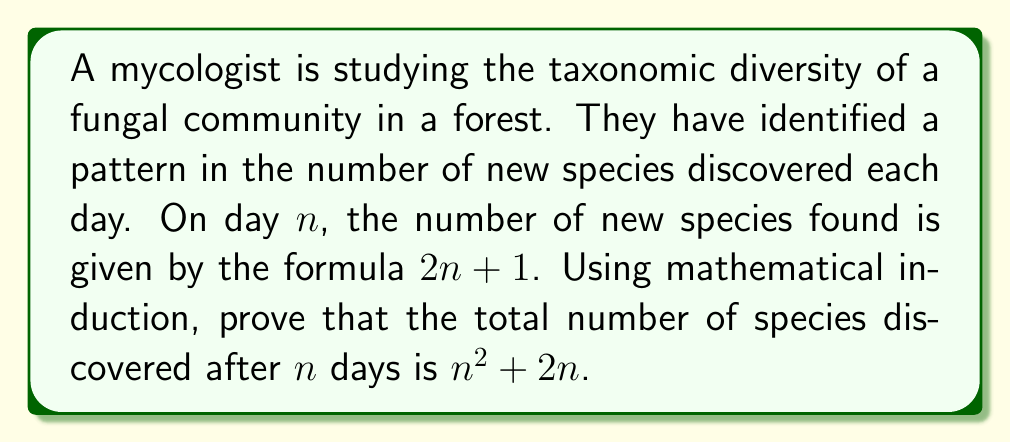Can you solve this math problem? To prove this statement using mathematical induction, we need to follow these steps:

1. Base case: Prove the statement is true for $n = 1$.
2. Inductive step: Assume the statement is true for some $k$, and prove it's true for $k + 1$.

Step 1: Base case $(n = 1)$
For the first day, the number of species discovered is:
$1^2 + 2(1) = 1 + 2 = 3$

This matches the formula $2n + 1$ for $n = 1$: $2(1) + 1 = 3$

Therefore, the base case is true.

Step 2: Inductive step
Assume the statement is true for $n = k$. That is, after $k$ days, the total number of species discovered is $k^2 + 2k$.

We need to prove it's true for $n = k + 1$.

The number of new species on day $k + 1$ is:
$2(k + 1) + 1 = 2k + 3$

The total number of species after $k + 1$ days is:
$$(k^2 + 2k) + (2k + 3)$$

Simplifying:
$$k^2 + 2k + 2k + 3$$
$$k^2 + 4k + 3$$
$$(k + 1)^2 + 2(k + 1)$$

This is exactly the formula we're trying to prove for $n = k + 1$.

Therefore, by the principle of mathematical induction, the statement is true for all positive integers $n$.
Answer: The total number of species discovered after $n$ days is $n^2 + 2n$. 